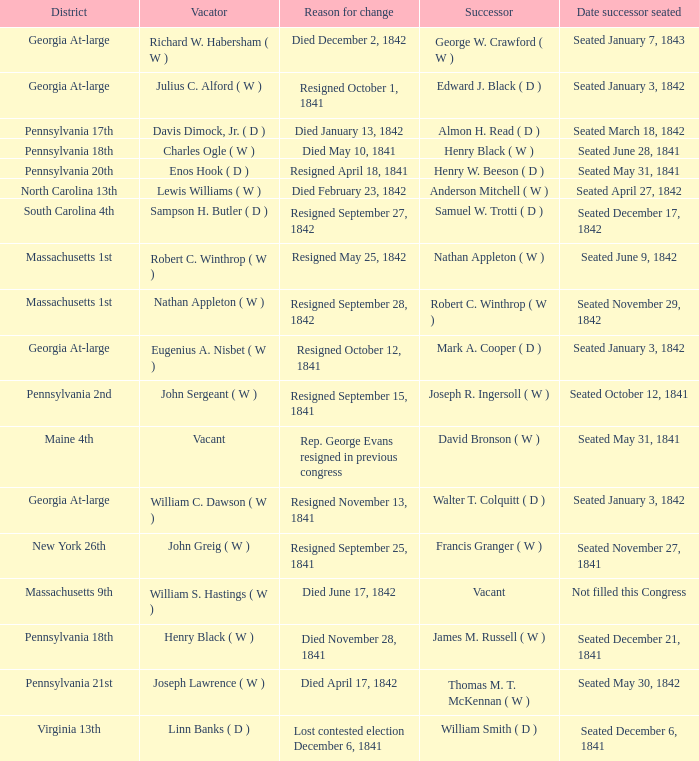Name the successor for north carolina 13th Anderson Mitchell ( W ). 